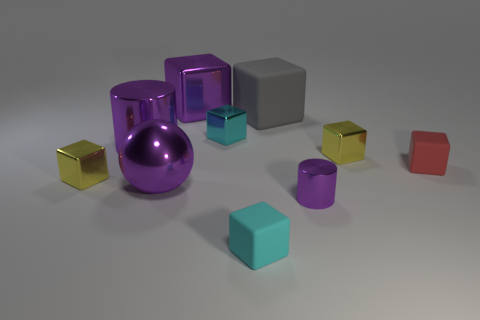Subtract all yellow cubes. How many cubes are left? 5 Subtract 2 blocks. How many blocks are left? 5 Subtract all yellow metallic blocks. How many blocks are left? 5 Subtract all purple cubes. Subtract all gray cylinders. How many cubes are left? 6 Subtract all balls. How many objects are left? 9 Add 7 small metal cubes. How many small metal cubes are left? 10 Add 7 tiny purple cylinders. How many tiny purple cylinders exist? 8 Subtract 0 yellow cylinders. How many objects are left? 10 Subtract all small yellow shiny cubes. Subtract all large rubber blocks. How many objects are left? 7 